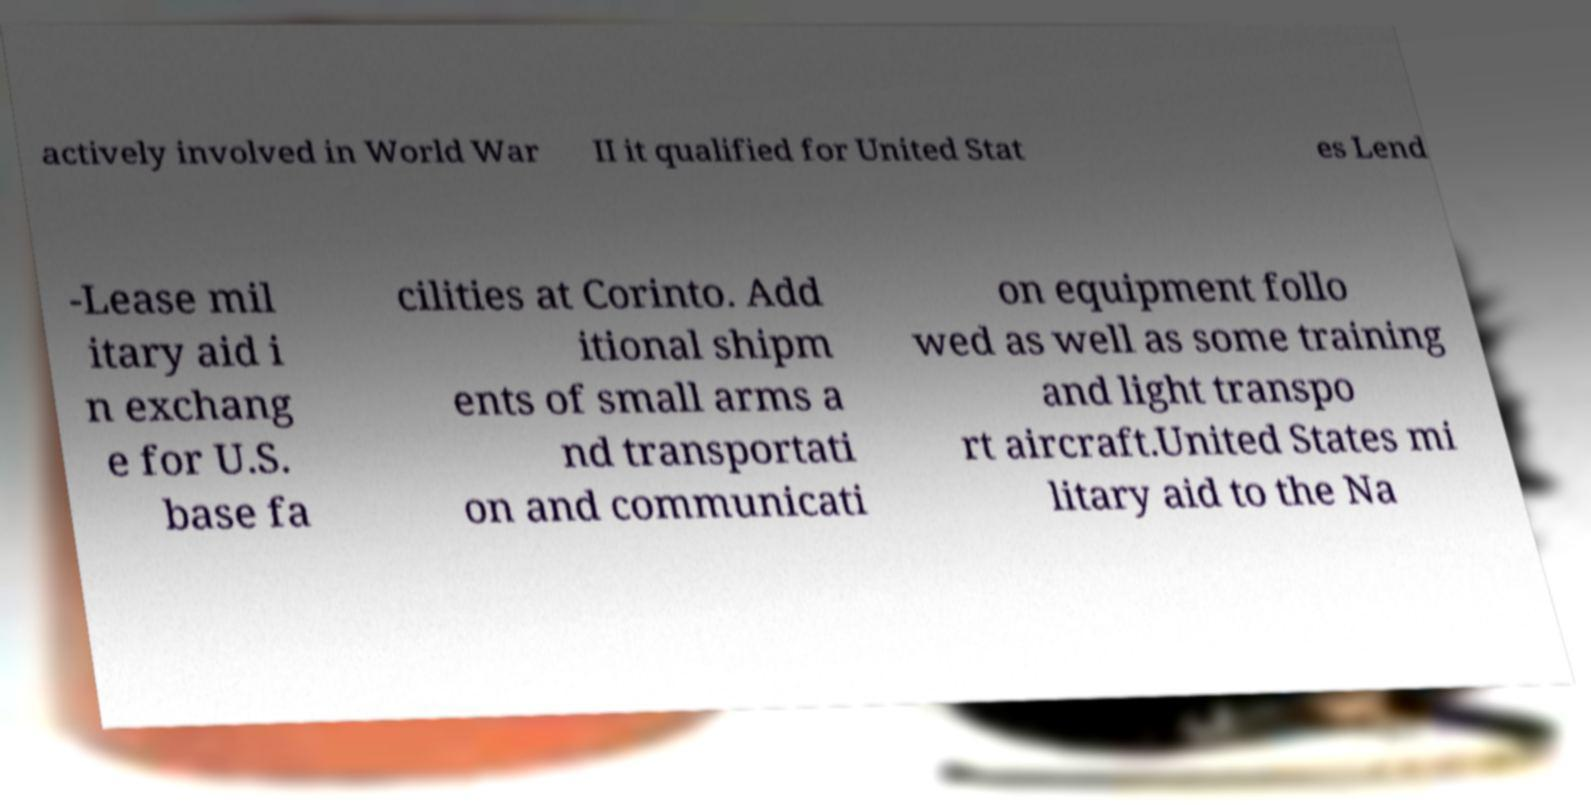Could you extract and type out the text from this image? actively involved in World War II it qualified for United Stat es Lend -Lease mil itary aid i n exchang e for U.S. base fa cilities at Corinto. Add itional shipm ents of small arms a nd transportati on and communicati on equipment follo wed as well as some training and light transpo rt aircraft.United States mi litary aid to the Na 